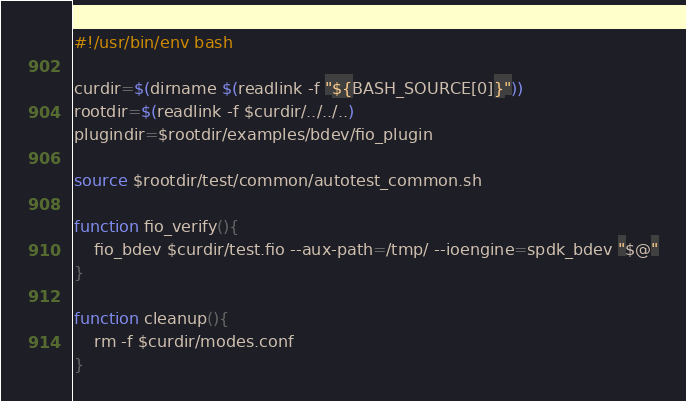Convert code to text. <code><loc_0><loc_0><loc_500><loc_500><_Bash_>#!/usr/bin/env bash

curdir=$(dirname $(readlink -f "${BASH_SOURCE[0]}"))
rootdir=$(readlink -f $curdir/../../..)
plugindir=$rootdir/examples/bdev/fio_plugin

source $rootdir/test/common/autotest_common.sh

function fio_verify(){
	fio_bdev $curdir/test.fio --aux-path=/tmp/ --ioengine=spdk_bdev "$@"
}

function cleanup(){
	rm -f $curdir/modes.conf
}
</code> 